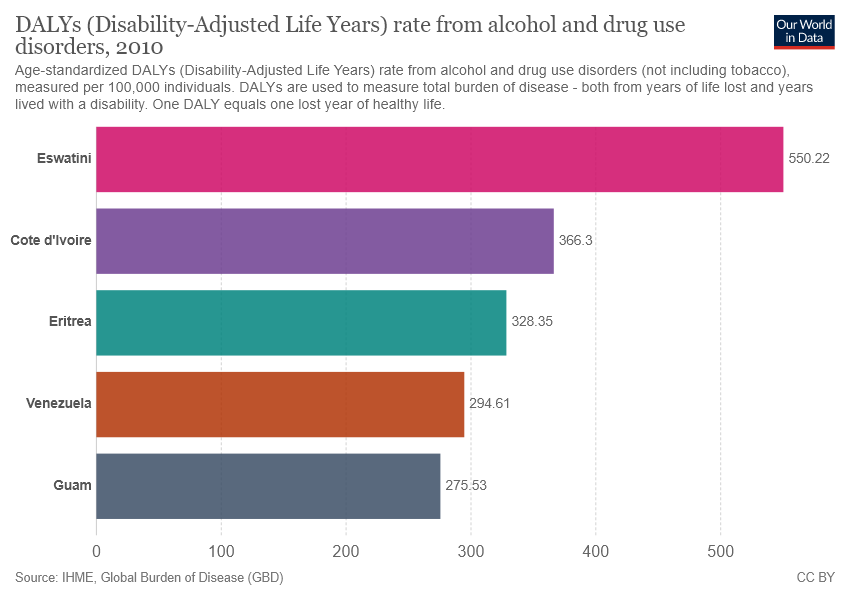Point out several critical features in this image. The median value of all bars is different from the lowest value by 52.82. According to the data, Eswatini has the highest value of DALYs rate from alcohol and drug use disorders among all countries and regions. 